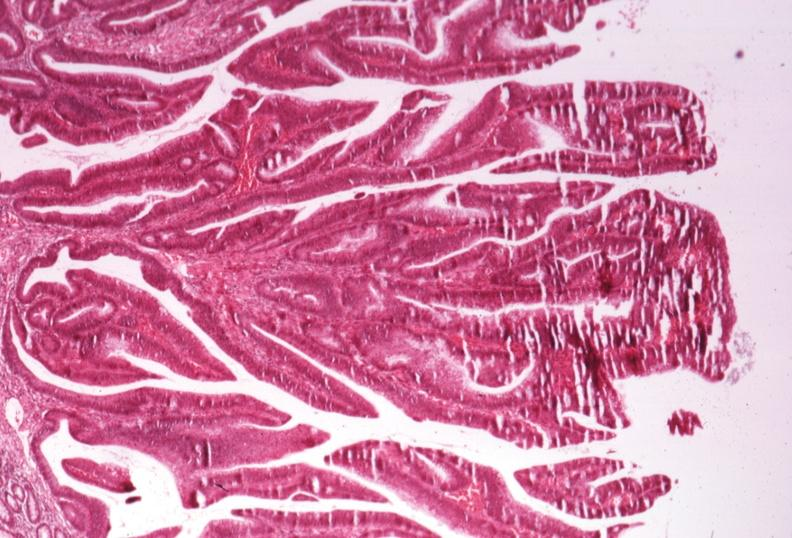s colon present?
Answer the question using a single word or phrase. Yes 